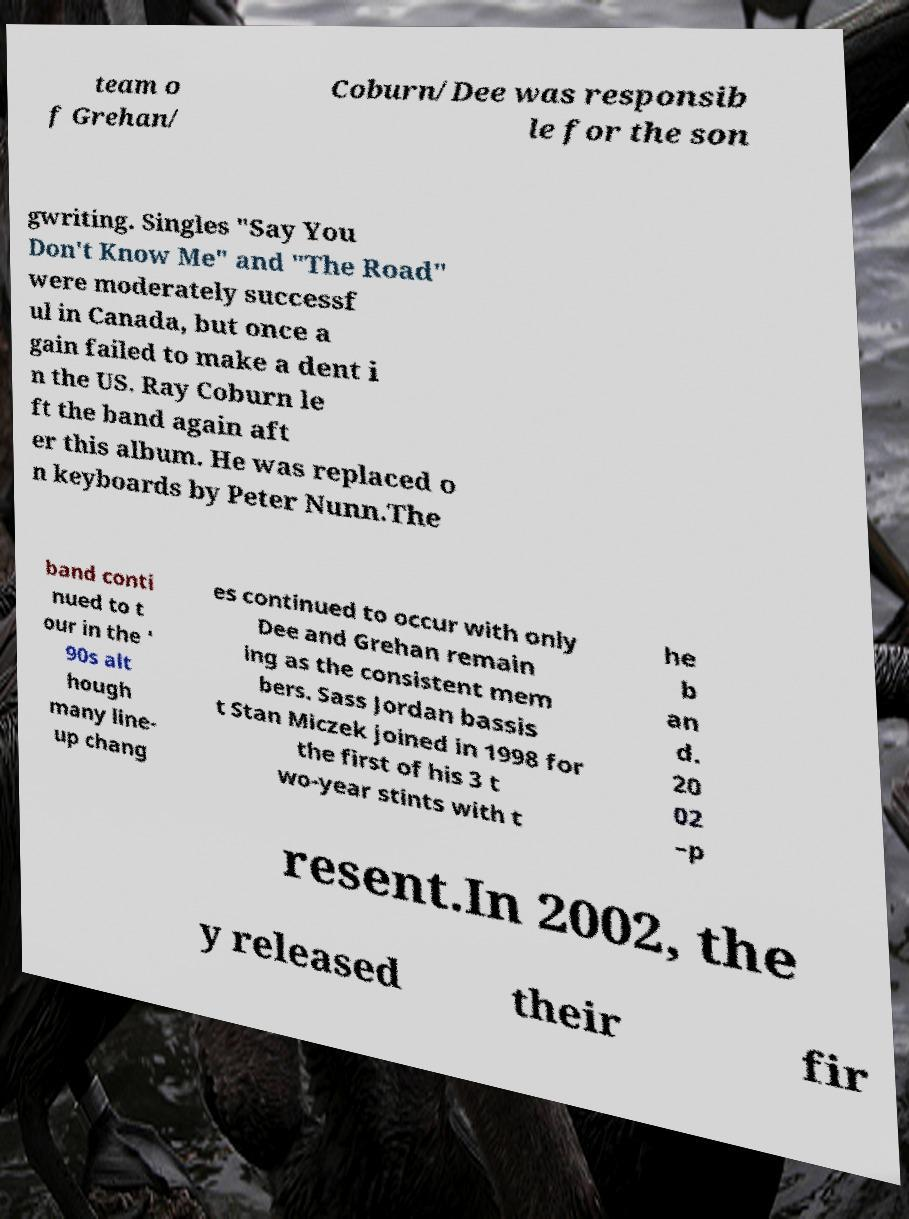Could you extract and type out the text from this image? team o f Grehan/ Coburn/Dee was responsib le for the son gwriting. Singles "Say You Don't Know Me" and "The Road" were moderately successf ul in Canada, but once a gain failed to make a dent i n the US. Ray Coburn le ft the band again aft er this album. He was replaced o n keyboards by Peter Nunn.The band conti nued to t our in the ' 90s alt hough many line- up chang es continued to occur with only Dee and Grehan remain ing as the consistent mem bers. Sass Jordan bassis t Stan Miczek joined in 1998 for the first of his 3 t wo-year stints with t he b an d. 20 02 –p resent.In 2002, the y released their fir 